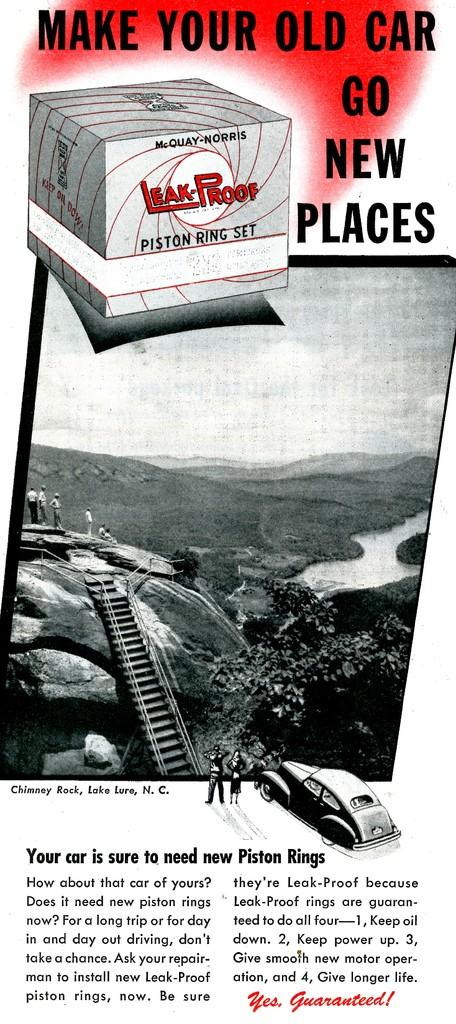<image>
Write a terse but informative summary of the picture. an advertisement that says to make your old car go new places 